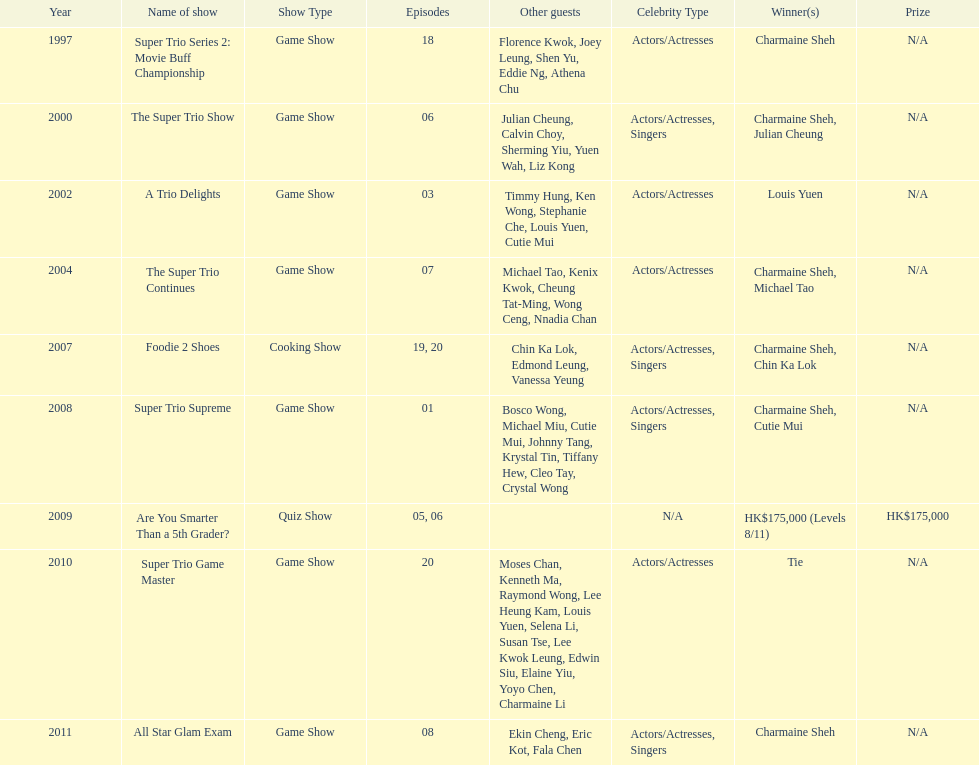How many tv shows has charmaine sheh been featured in? 9. 